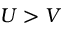Convert formula to latex. <formula><loc_0><loc_0><loc_500><loc_500>U > V</formula> 